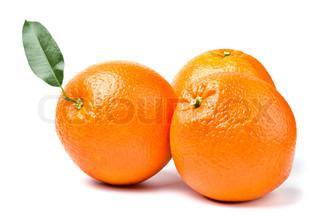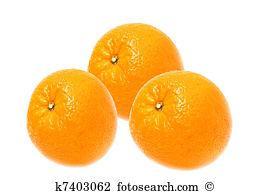The first image is the image on the left, the second image is the image on the right. Assess this claim about the two images: "There are six oranges.". Correct or not? Answer yes or no. Yes. 